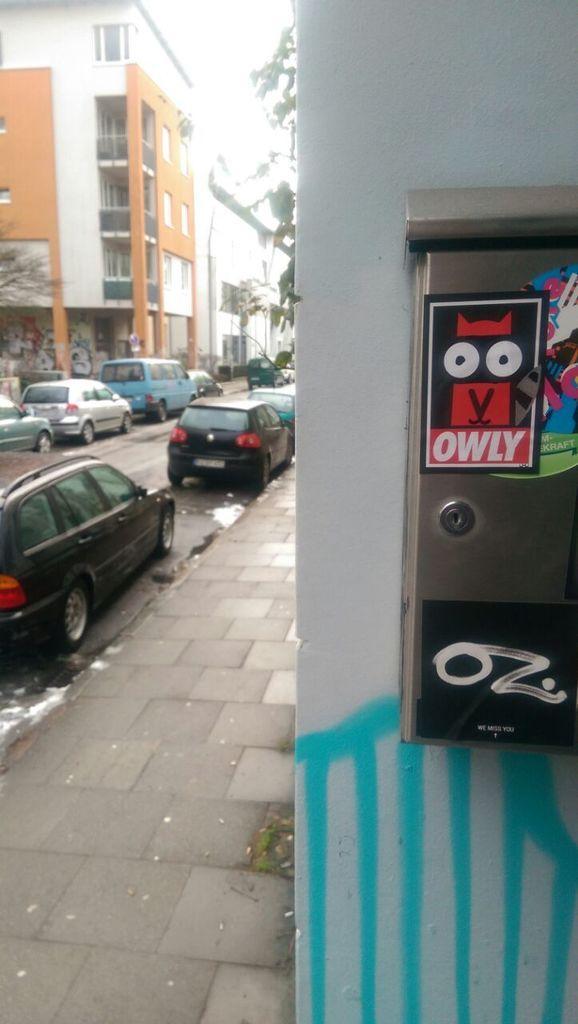Can you describe this image briefly? In this image we can see can see buildings. On the left there are cars on the road. In the background there are trees and sky. 